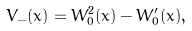Convert formula to latex. <formula><loc_0><loc_0><loc_500><loc_500>V _ { - } ( x ) = W _ { 0 } ^ { 2 } ( x ) - W _ { 0 } ^ { \prime } ( x ) ,</formula> 